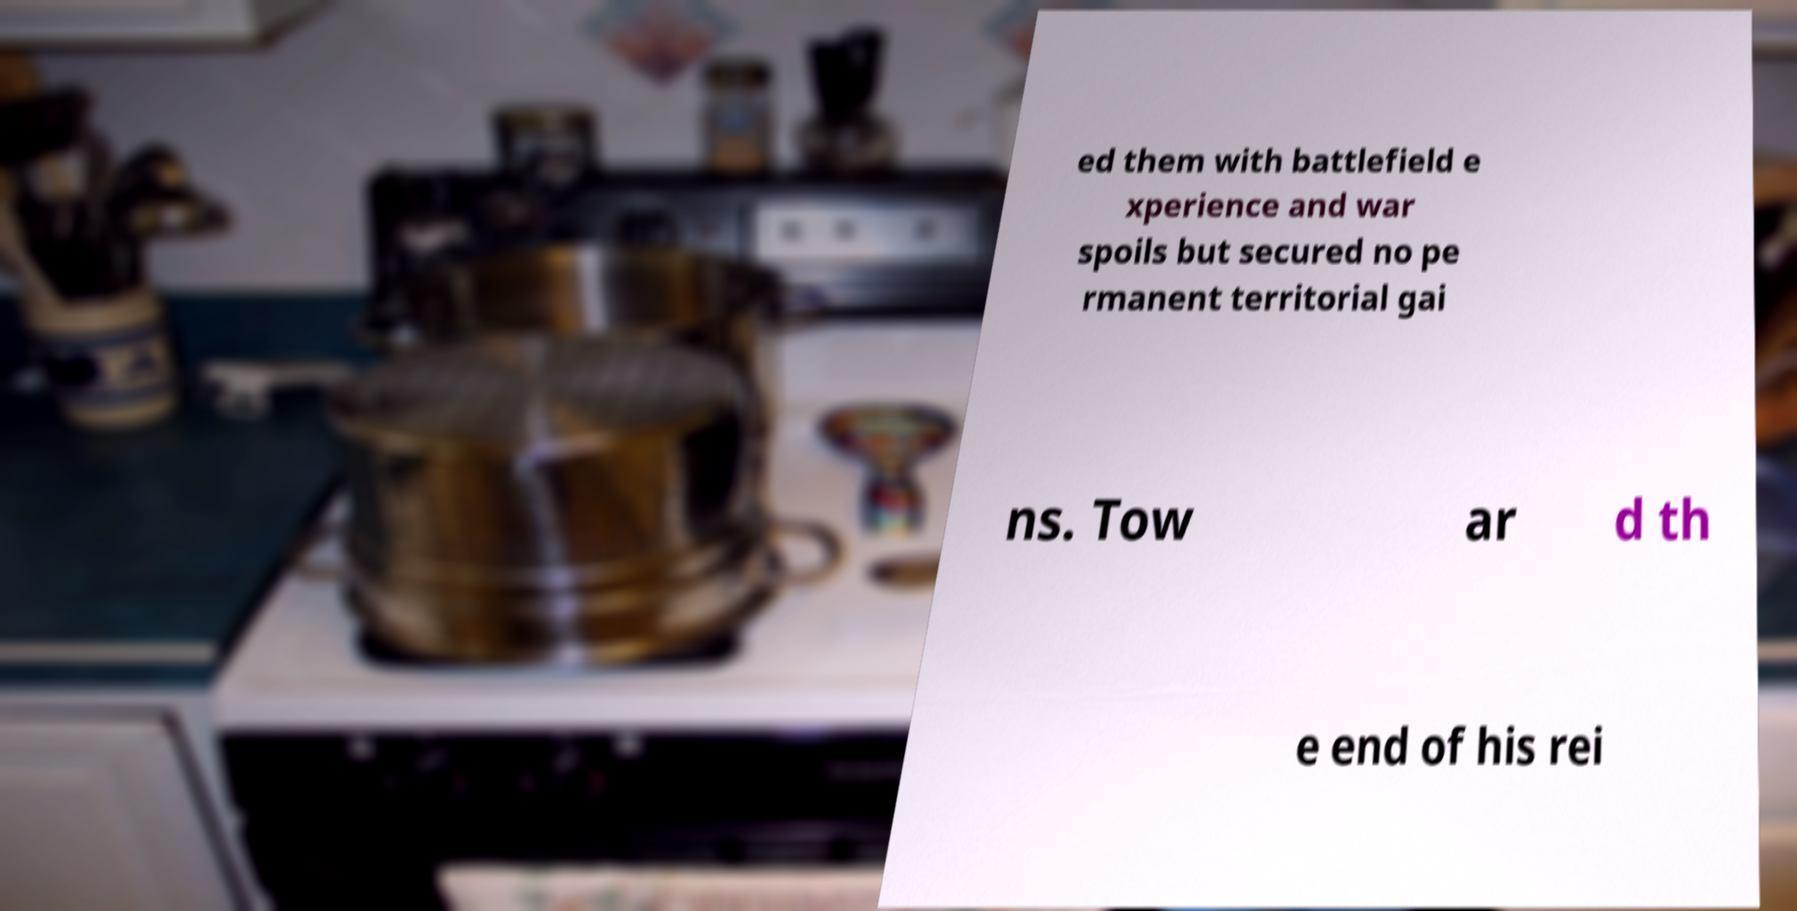For documentation purposes, I need the text within this image transcribed. Could you provide that? ed them with battlefield e xperience and war spoils but secured no pe rmanent territorial gai ns. Tow ar d th e end of his rei 